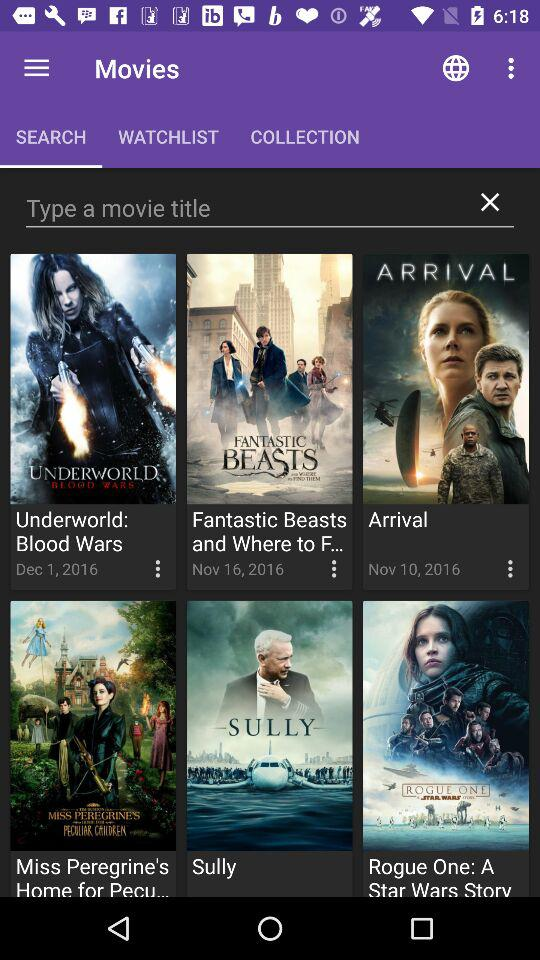How many name of movie title in this?
When the provided information is insufficient, respond with <no answer>. <no answer> 